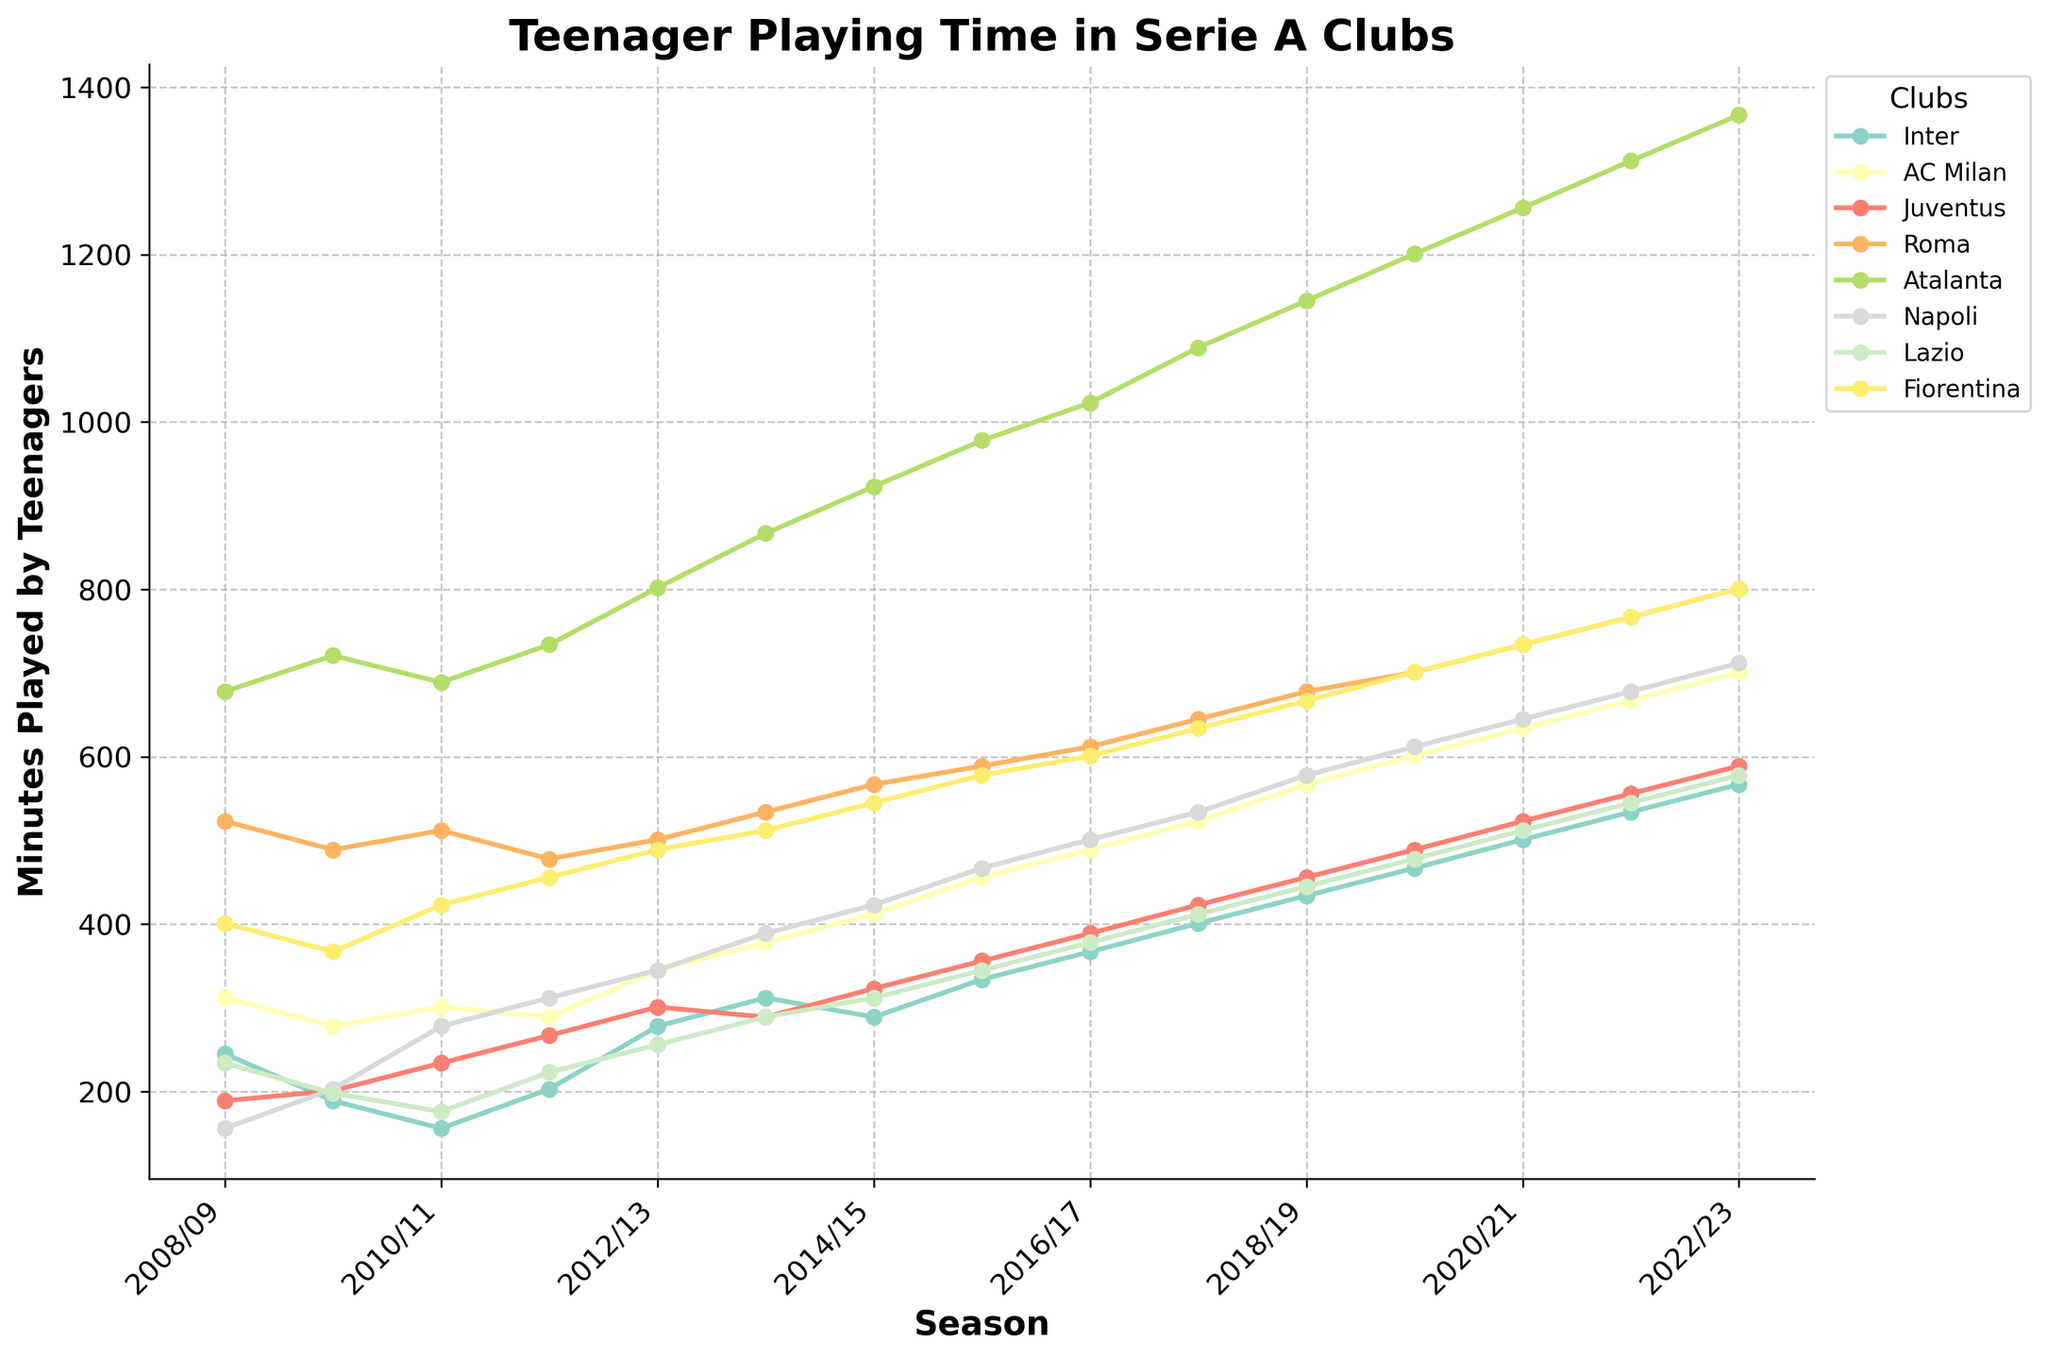How many seasons did Fiorentina have more minutes played by teenagers than Inter? First, observe the line graphs for Fiorentina and Inter over the 15 seasons. For each season where Fiorentina's line is above Inter's line, count those seasons. The seasons are 2012/13 to 2022/23.
Answer: 11 Which club showed the most significant increase in teenage minutes played from the 2008/09 season to the 2022/23 season? Calculate the difference in teenage minutes played between the 2022/23 season and the 2008/09 season for each club. Atalanta shows the most significant increase, from 678 to 1367.
Answer: Atalanta In which season did Roma have the highest minutes played by teenagers, and what was the value? Identify the highest point on Roma's line graph across the seasons. The peak is at the 2022/23 season with 801 minutes played.
Answer: 2022/23, 801 During which seasons did Juventus have teenage minutes played higher than 500? Check the line graph for Juventus and identify all seasons where the value is higher than 500. The seasons are 2016/17 to 2022/23.
Answer: 7 In the 2013/14 season, how much more were the minutes played by teenagers in Atalanta compared to Juventus? Find the corresponding values on the line graphs for Atalanta and Juventus for the 2013/14 season. Subtract the value for Juventus from the value for Atalanta (867 - 289).
Answer: 578 How does the trend in teenage minutes played by Lazio compare to that of Napoli from 2010/11 to 2015/16? Observe the line graphs for Lazio and Napoli between 2010/11 and 2015/16. Lazio’s minutes played trend upwards from 176 to 345, whereas Napoli’s line also trends upwards from 278 to 467. Both clubs show a general upward trend in this period.
Answer: Upward Trend for Both Which club had the most stable (least fluctuating) amount of teenage minutes played across the 15 seasons? Evaluate the line graphs for each club and compare the fluctuations. Inter shows the least fluctuation with a relatively steady increase over the years.
Answer: Inter What is the combined total of minutes played by teenagers in the 2020/21 season for AC Milan and Fiorentina? Add the values for AC Milan and Fiorentina in the 2020/21 season from the line graph (634 + 734).
Answer: 1368 